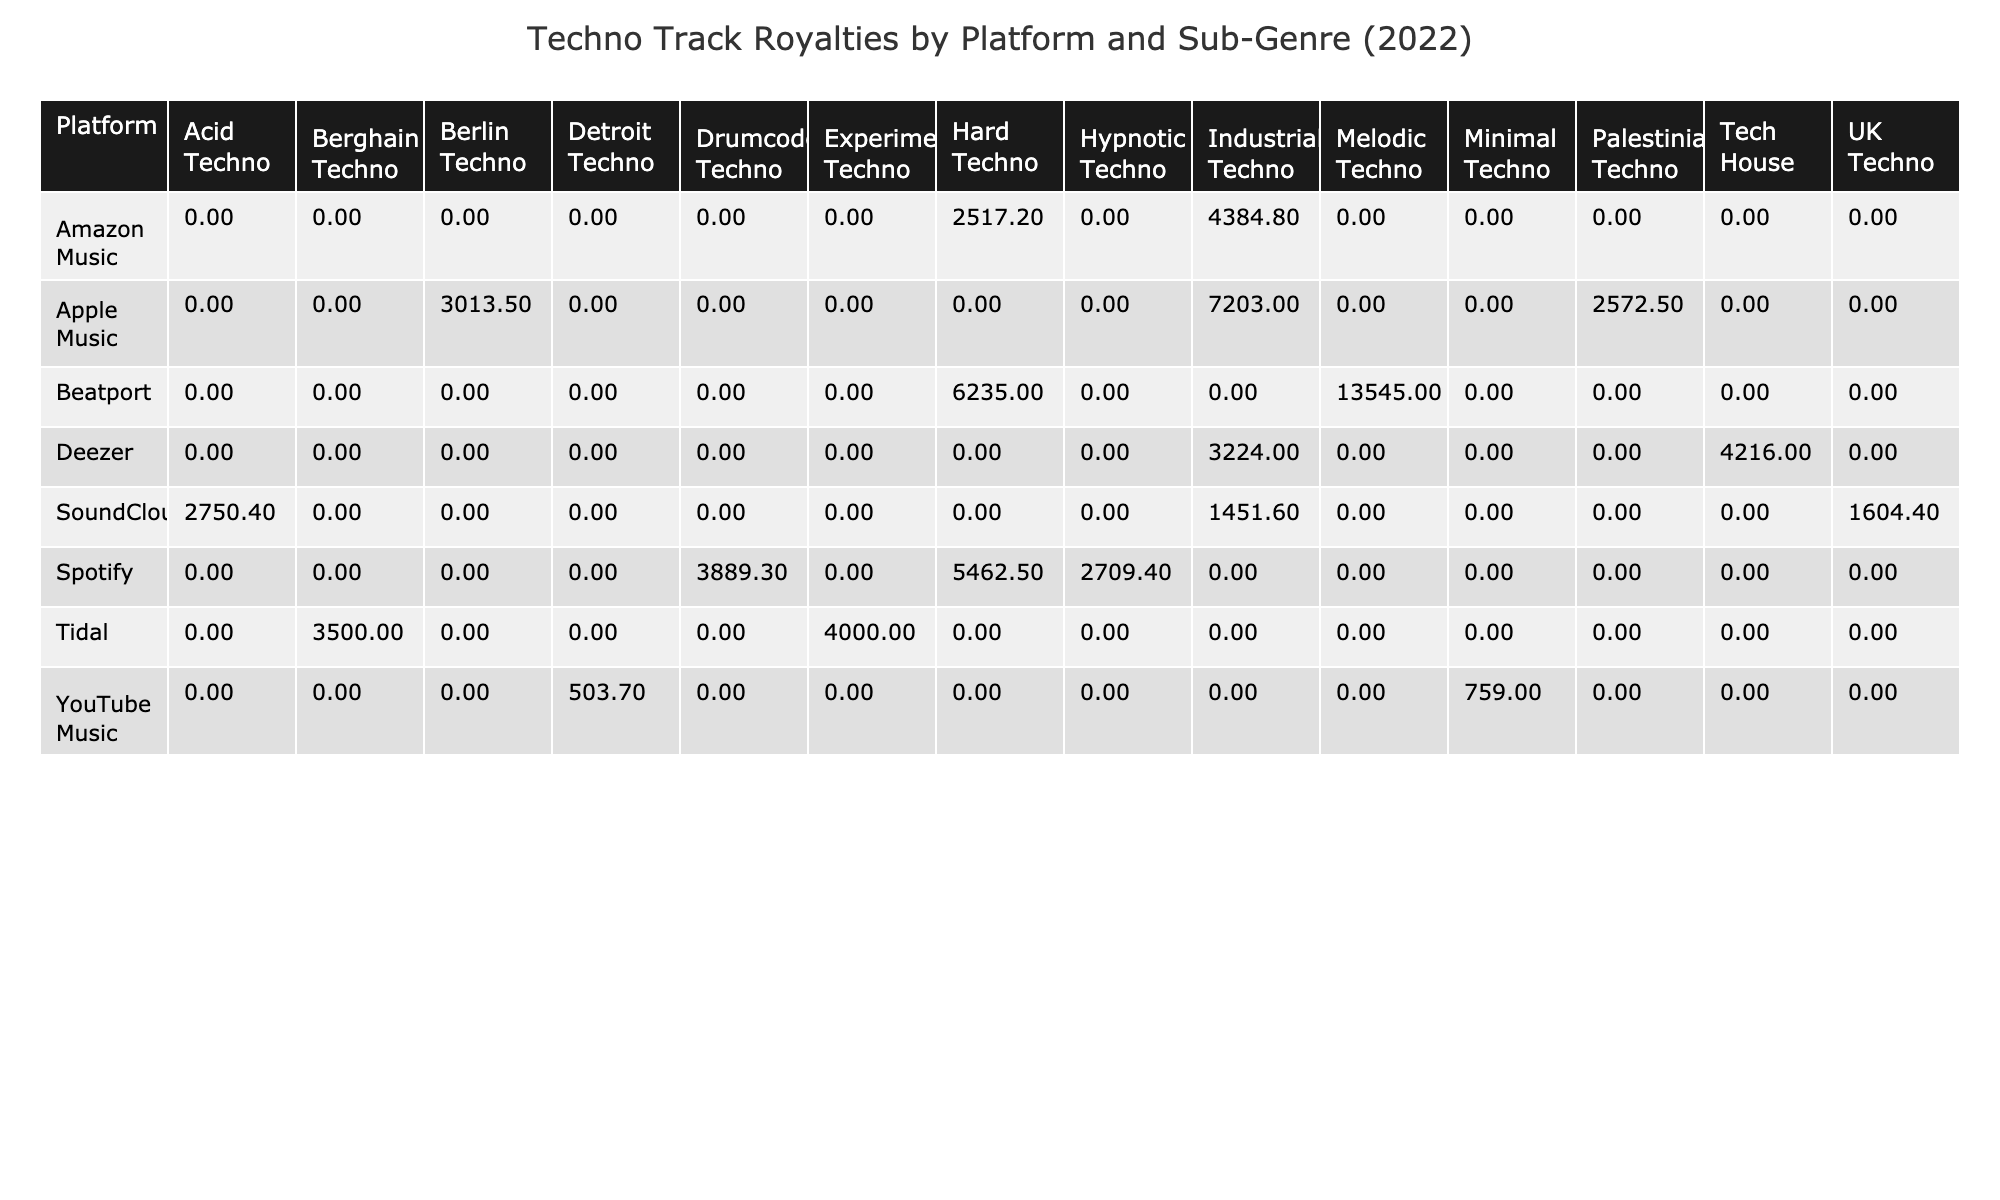What is the total royalty amount for Spotify tracks? To find the total royalties for Spotify tracks, we look at the Total Royalties column for Spotify rows: 5462.50 + 3889.30 + 2709.40 = 12061.20.
Answer: 12061.20 Which platform generated the highest total royalties? The highest total royalties can be found by comparing the total amounts listed for each platform. Looking at the sum, Beatport has 9675.00 + 6235.00 = 15910.00, which is the highest total compared to other platforms.
Answer: Beatport What is the average royalty rate for tracks in the Acid Techno sub-genre? For Acid Techno, there is one track listed: “Werewolf Disco Club” with a royalty rate of 0.00382. Since there’s only one track, the average is the same as the sole value of 0.00382.
Answer: 0.00382 Did any track in the Industrial Techno sub-genre earn more than 5000 in royalties? There are two tracks in the Industrial Techno sub-genre. "Higher" earned 7203.00 and "Anxiety" earned 2517.20. Since 7203.00 > 5000, the answer is yes.
Answer: Yes What is the total royalty amount generated by Deezer tracks? Looking at the Deezer tracks, the total royalties are 4216.00 (Electronic Generations) + 3224.00 (44 Rush) = 7439.00.
Answer: 7439.00 Which sub-genre had the least total royalties across all platforms? Analyzing the Total Royalties column for all sub-genres shows that Minimal Techno has 759.00, which is the lowest amount.
Answer: Minimal Techno How many initial releases were in the month of March 2022? The dataset shows two tracks were released in March 2022: "Doppler" and "44 Rush." So, there are 2 initial releases in March.
Answer: 2 Which artist had the highest individual track royalties? The highest individual track royalties can be determined by reviewing the Total Royalties column. "Journey to the Underworld" by ANNA has 9675.00, which is the highest.
Answer: ANNA What is the total royalty earnings for tracks released in the second half of the year (July-December)? Looking at the release dates in the second half of the year: "Colonized" (4384.80) + "Anxiety" (2517.20) + "Offending Public Morality" (1451.60) = 8353.60.
Answer: 8353.60 